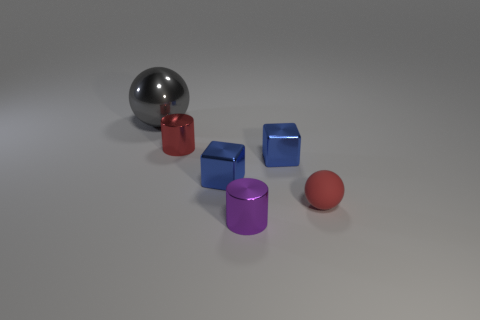Is there anything else that is the same size as the gray metallic thing?
Your answer should be very brief. No. Are there any other things that are the same material as the tiny red ball?
Keep it short and to the point. No. The metal cylinder that is in front of the small red object on the left side of the matte sphere is what color?
Provide a short and direct response. Purple. Is there a cylinder of the same color as the matte thing?
Offer a very short reply. Yes. What number of matte objects are small cyan balls or purple cylinders?
Offer a very short reply. 0. Are there any blue objects made of the same material as the red cylinder?
Offer a terse response. Yes. How many metal objects are both behind the red metallic cylinder and right of the gray sphere?
Make the answer very short. 0. Is the number of large things behind the small red ball less than the number of small metallic objects to the left of the large gray metal thing?
Your answer should be very brief. No. Is the gray thing the same shape as the tiny purple object?
Provide a succinct answer. No. How many other objects are the same size as the gray metallic object?
Your answer should be compact. 0. 